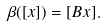Convert formula to latex. <formula><loc_0><loc_0><loc_500><loc_500>\beta ( [ x ] ) = [ B x ] .</formula> 